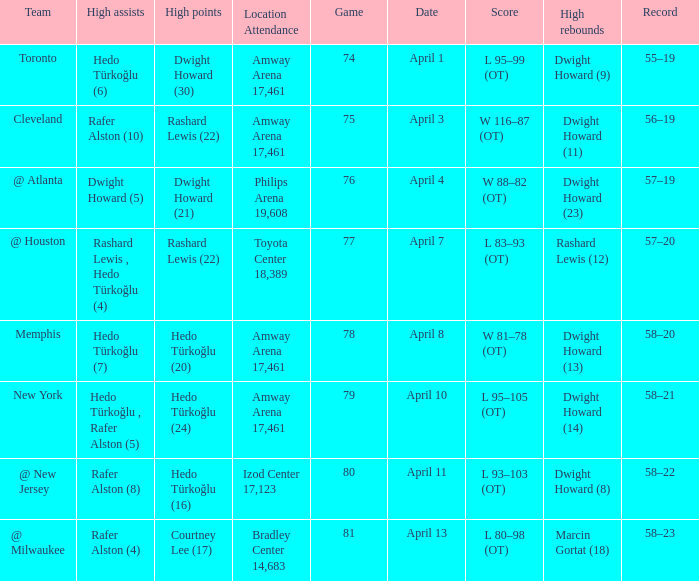Which player had the highest points in game 79? Hedo Türkoğlu (24). 